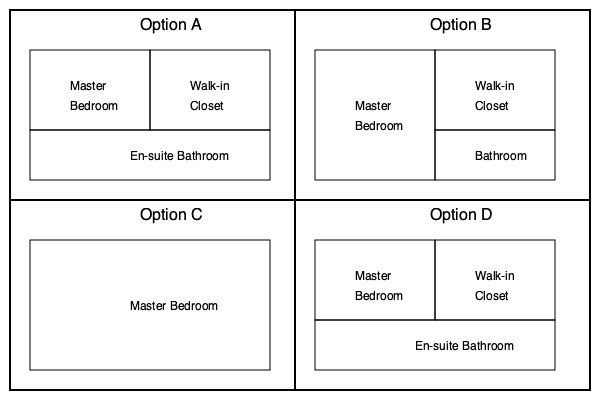Your client, a wealthy heiress, is going through a divorce and wants to ensure her prenuptial agreement protects her family's mansion. The mansion's master suite is described as having a spacious master bedroom, a large walk-in closet, and an en-suite bathroom all on one side of the house. Based on this description, which floor plan option best represents the layout of the master suite? To determine the correct floor plan layout, let's analyze each option based on the given description:

1. The description mentions three key elements: master bedroom, walk-in closet, and en-suite bathroom.
2. These elements should all be on one side of the house.

Let's examine each option:

Option A:
- Has a master bedroom and walk-in closet side by side
- En-suite bathroom is below these rooms
- All elements are on one side of the house
- Matches the description

Option B:
- Has a master bedroom and walk-in closet side by side
- Bathroom is separate and not connected
- Does not match the description of an en-suite bathroom

Option C:
- Has a large room labeled as the master bedroom
- No separate walk-in closet
- No visible bathroom
- Does not match the description

Option D:
- Has a master bedroom and walk-in closet side by side
- En-suite bathroom is below these rooms
- All elements are on one side of the house
- Matches the description

Both Options A and D match the description. However, Option A is typically considered the more standard layout for a master suite, with the bathroom directly accessible from the bedroom.
Answer: Option A 